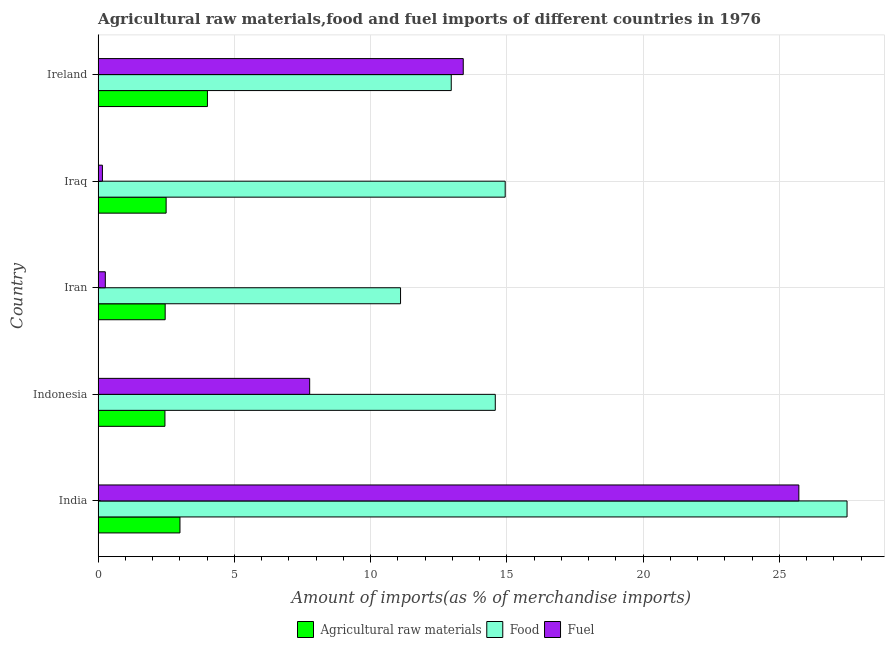How many groups of bars are there?
Give a very brief answer. 5. Are the number of bars on each tick of the Y-axis equal?
Provide a succinct answer. Yes. How many bars are there on the 3rd tick from the bottom?
Your response must be concise. 3. What is the label of the 4th group of bars from the top?
Offer a terse response. Indonesia. In how many cases, is the number of bars for a given country not equal to the number of legend labels?
Offer a terse response. 0. What is the percentage of raw materials imports in Iran?
Make the answer very short. 2.46. Across all countries, what is the maximum percentage of fuel imports?
Keep it short and to the point. 25.71. Across all countries, what is the minimum percentage of fuel imports?
Your response must be concise. 0.16. In which country was the percentage of food imports minimum?
Ensure brevity in your answer.  Iran. What is the total percentage of food imports in the graph?
Give a very brief answer. 81.05. What is the difference between the percentage of fuel imports in Indonesia and that in Ireland?
Provide a short and direct response. -5.63. What is the difference between the percentage of food imports in Ireland and the percentage of fuel imports in India?
Provide a succinct answer. -12.75. What is the average percentage of fuel imports per country?
Offer a terse response. 9.46. What is the difference between the percentage of raw materials imports and percentage of fuel imports in Iraq?
Ensure brevity in your answer.  2.34. In how many countries, is the percentage of raw materials imports greater than 3 %?
Ensure brevity in your answer.  2. What is the ratio of the percentage of food imports in India to that in Iraq?
Make the answer very short. 1.84. Is the percentage of raw materials imports in Indonesia less than that in Iraq?
Give a very brief answer. Yes. Is the difference between the percentage of raw materials imports in India and Ireland greater than the difference between the percentage of fuel imports in India and Ireland?
Offer a terse response. No. What is the difference between the highest and the second highest percentage of food imports?
Make the answer very short. 12.54. What is the difference between the highest and the lowest percentage of raw materials imports?
Ensure brevity in your answer.  1.56. In how many countries, is the percentage of fuel imports greater than the average percentage of fuel imports taken over all countries?
Offer a terse response. 2. What does the 3rd bar from the top in Iran represents?
Provide a short and direct response. Agricultural raw materials. What does the 1st bar from the bottom in Indonesia represents?
Provide a succinct answer. Agricultural raw materials. How many bars are there?
Your answer should be compact. 15. What is the difference between two consecutive major ticks on the X-axis?
Your answer should be compact. 5. Are the values on the major ticks of X-axis written in scientific E-notation?
Provide a succinct answer. No. Where does the legend appear in the graph?
Your answer should be compact. Bottom center. How are the legend labels stacked?
Ensure brevity in your answer.  Horizontal. What is the title of the graph?
Provide a short and direct response. Agricultural raw materials,food and fuel imports of different countries in 1976. What is the label or title of the X-axis?
Provide a short and direct response. Amount of imports(as % of merchandise imports). What is the Amount of imports(as % of merchandise imports) of Agricultural raw materials in India?
Keep it short and to the point. 3. What is the Amount of imports(as % of merchandise imports) of Food in India?
Provide a short and direct response. 27.48. What is the Amount of imports(as % of merchandise imports) of Fuel in India?
Offer a terse response. 25.71. What is the Amount of imports(as % of merchandise imports) of Agricultural raw materials in Indonesia?
Your response must be concise. 2.45. What is the Amount of imports(as % of merchandise imports) in Food in Indonesia?
Provide a succinct answer. 14.57. What is the Amount of imports(as % of merchandise imports) of Fuel in Indonesia?
Offer a terse response. 7.76. What is the Amount of imports(as % of merchandise imports) in Agricultural raw materials in Iran?
Your answer should be very brief. 2.46. What is the Amount of imports(as % of merchandise imports) of Food in Iran?
Offer a terse response. 11.1. What is the Amount of imports(as % of merchandise imports) in Fuel in Iran?
Your answer should be very brief. 0.26. What is the Amount of imports(as % of merchandise imports) in Agricultural raw materials in Iraq?
Ensure brevity in your answer.  2.5. What is the Amount of imports(as % of merchandise imports) of Food in Iraq?
Provide a succinct answer. 14.94. What is the Amount of imports(as % of merchandise imports) in Fuel in Iraq?
Your answer should be compact. 0.16. What is the Amount of imports(as % of merchandise imports) of Agricultural raw materials in Ireland?
Your answer should be compact. 4.01. What is the Amount of imports(as % of merchandise imports) in Food in Ireland?
Your response must be concise. 12.96. What is the Amount of imports(as % of merchandise imports) of Fuel in Ireland?
Give a very brief answer. 13.4. Across all countries, what is the maximum Amount of imports(as % of merchandise imports) in Agricultural raw materials?
Provide a succinct answer. 4.01. Across all countries, what is the maximum Amount of imports(as % of merchandise imports) of Food?
Your answer should be compact. 27.48. Across all countries, what is the maximum Amount of imports(as % of merchandise imports) of Fuel?
Keep it short and to the point. 25.71. Across all countries, what is the minimum Amount of imports(as % of merchandise imports) in Agricultural raw materials?
Provide a short and direct response. 2.45. Across all countries, what is the minimum Amount of imports(as % of merchandise imports) of Food?
Your answer should be compact. 11.1. Across all countries, what is the minimum Amount of imports(as % of merchandise imports) in Fuel?
Provide a short and direct response. 0.16. What is the total Amount of imports(as % of merchandise imports) in Agricultural raw materials in the graph?
Provide a succinct answer. 14.42. What is the total Amount of imports(as % of merchandise imports) in Food in the graph?
Your answer should be compact. 81.05. What is the total Amount of imports(as % of merchandise imports) of Fuel in the graph?
Offer a very short reply. 47.29. What is the difference between the Amount of imports(as % of merchandise imports) in Agricultural raw materials in India and that in Indonesia?
Ensure brevity in your answer.  0.55. What is the difference between the Amount of imports(as % of merchandise imports) in Food in India and that in Indonesia?
Keep it short and to the point. 12.91. What is the difference between the Amount of imports(as % of merchandise imports) in Fuel in India and that in Indonesia?
Provide a succinct answer. 17.95. What is the difference between the Amount of imports(as % of merchandise imports) of Agricultural raw materials in India and that in Iran?
Offer a very short reply. 0.54. What is the difference between the Amount of imports(as % of merchandise imports) in Food in India and that in Iran?
Offer a very short reply. 16.38. What is the difference between the Amount of imports(as % of merchandise imports) in Fuel in India and that in Iran?
Your response must be concise. 25.45. What is the difference between the Amount of imports(as % of merchandise imports) of Agricultural raw materials in India and that in Iraq?
Make the answer very short. 0.51. What is the difference between the Amount of imports(as % of merchandise imports) of Food in India and that in Iraq?
Your response must be concise. 12.54. What is the difference between the Amount of imports(as % of merchandise imports) in Fuel in India and that in Iraq?
Make the answer very short. 25.55. What is the difference between the Amount of imports(as % of merchandise imports) of Agricultural raw materials in India and that in Ireland?
Offer a terse response. -1.01. What is the difference between the Amount of imports(as % of merchandise imports) in Food in India and that in Ireland?
Keep it short and to the point. 14.52. What is the difference between the Amount of imports(as % of merchandise imports) of Fuel in India and that in Ireland?
Provide a succinct answer. 12.31. What is the difference between the Amount of imports(as % of merchandise imports) in Agricultural raw materials in Indonesia and that in Iran?
Provide a succinct answer. -0.01. What is the difference between the Amount of imports(as % of merchandise imports) in Food in Indonesia and that in Iran?
Offer a very short reply. 3.48. What is the difference between the Amount of imports(as % of merchandise imports) in Fuel in Indonesia and that in Iran?
Offer a terse response. 7.5. What is the difference between the Amount of imports(as % of merchandise imports) of Agricultural raw materials in Indonesia and that in Iraq?
Keep it short and to the point. -0.04. What is the difference between the Amount of imports(as % of merchandise imports) of Food in Indonesia and that in Iraq?
Your answer should be very brief. -0.36. What is the difference between the Amount of imports(as % of merchandise imports) in Fuel in Indonesia and that in Iraq?
Give a very brief answer. 7.6. What is the difference between the Amount of imports(as % of merchandise imports) in Agricultural raw materials in Indonesia and that in Ireland?
Ensure brevity in your answer.  -1.56. What is the difference between the Amount of imports(as % of merchandise imports) of Food in Indonesia and that in Ireland?
Make the answer very short. 1.62. What is the difference between the Amount of imports(as % of merchandise imports) of Fuel in Indonesia and that in Ireland?
Provide a short and direct response. -5.64. What is the difference between the Amount of imports(as % of merchandise imports) in Agricultural raw materials in Iran and that in Iraq?
Ensure brevity in your answer.  -0.04. What is the difference between the Amount of imports(as % of merchandise imports) in Food in Iran and that in Iraq?
Your response must be concise. -3.84. What is the difference between the Amount of imports(as % of merchandise imports) in Fuel in Iran and that in Iraq?
Make the answer very short. 0.11. What is the difference between the Amount of imports(as % of merchandise imports) in Agricultural raw materials in Iran and that in Ireland?
Keep it short and to the point. -1.55. What is the difference between the Amount of imports(as % of merchandise imports) in Food in Iran and that in Ireland?
Make the answer very short. -1.86. What is the difference between the Amount of imports(as % of merchandise imports) in Fuel in Iran and that in Ireland?
Make the answer very short. -13.13. What is the difference between the Amount of imports(as % of merchandise imports) in Agricultural raw materials in Iraq and that in Ireland?
Provide a succinct answer. -1.52. What is the difference between the Amount of imports(as % of merchandise imports) in Food in Iraq and that in Ireland?
Ensure brevity in your answer.  1.98. What is the difference between the Amount of imports(as % of merchandise imports) of Fuel in Iraq and that in Ireland?
Offer a very short reply. -13.24. What is the difference between the Amount of imports(as % of merchandise imports) of Agricultural raw materials in India and the Amount of imports(as % of merchandise imports) of Food in Indonesia?
Your answer should be very brief. -11.57. What is the difference between the Amount of imports(as % of merchandise imports) in Agricultural raw materials in India and the Amount of imports(as % of merchandise imports) in Fuel in Indonesia?
Ensure brevity in your answer.  -4.76. What is the difference between the Amount of imports(as % of merchandise imports) in Food in India and the Amount of imports(as % of merchandise imports) in Fuel in Indonesia?
Make the answer very short. 19.72. What is the difference between the Amount of imports(as % of merchandise imports) in Agricultural raw materials in India and the Amount of imports(as % of merchandise imports) in Food in Iran?
Provide a short and direct response. -8.09. What is the difference between the Amount of imports(as % of merchandise imports) of Agricultural raw materials in India and the Amount of imports(as % of merchandise imports) of Fuel in Iran?
Provide a succinct answer. 2.74. What is the difference between the Amount of imports(as % of merchandise imports) of Food in India and the Amount of imports(as % of merchandise imports) of Fuel in Iran?
Keep it short and to the point. 27.22. What is the difference between the Amount of imports(as % of merchandise imports) in Agricultural raw materials in India and the Amount of imports(as % of merchandise imports) in Food in Iraq?
Offer a terse response. -11.93. What is the difference between the Amount of imports(as % of merchandise imports) in Agricultural raw materials in India and the Amount of imports(as % of merchandise imports) in Fuel in Iraq?
Keep it short and to the point. 2.85. What is the difference between the Amount of imports(as % of merchandise imports) of Food in India and the Amount of imports(as % of merchandise imports) of Fuel in Iraq?
Give a very brief answer. 27.32. What is the difference between the Amount of imports(as % of merchandise imports) of Agricultural raw materials in India and the Amount of imports(as % of merchandise imports) of Food in Ireland?
Provide a succinct answer. -9.95. What is the difference between the Amount of imports(as % of merchandise imports) in Agricultural raw materials in India and the Amount of imports(as % of merchandise imports) in Fuel in Ireland?
Your response must be concise. -10.39. What is the difference between the Amount of imports(as % of merchandise imports) in Food in India and the Amount of imports(as % of merchandise imports) in Fuel in Ireland?
Make the answer very short. 14.08. What is the difference between the Amount of imports(as % of merchandise imports) of Agricultural raw materials in Indonesia and the Amount of imports(as % of merchandise imports) of Food in Iran?
Provide a succinct answer. -8.65. What is the difference between the Amount of imports(as % of merchandise imports) in Agricultural raw materials in Indonesia and the Amount of imports(as % of merchandise imports) in Fuel in Iran?
Offer a very short reply. 2.19. What is the difference between the Amount of imports(as % of merchandise imports) in Food in Indonesia and the Amount of imports(as % of merchandise imports) in Fuel in Iran?
Offer a terse response. 14.31. What is the difference between the Amount of imports(as % of merchandise imports) of Agricultural raw materials in Indonesia and the Amount of imports(as % of merchandise imports) of Food in Iraq?
Provide a short and direct response. -12.48. What is the difference between the Amount of imports(as % of merchandise imports) in Agricultural raw materials in Indonesia and the Amount of imports(as % of merchandise imports) in Fuel in Iraq?
Provide a short and direct response. 2.29. What is the difference between the Amount of imports(as % of merchandise imports) in Food in Indonesia and the Amount of imports(as % of merchandise imports) in Fuel in Iraq?
Keep it short and to the point. 14.42. What is the difference between the Amount of imports(as % of merchandise imports) of Agricultural raw materials in Indonesia and the Amount of imports(as % of merchandise imports) of Food in Ireland?
Offer a very short reply. -10.51. What is the difference between the Amount of imports(as % of merchandise imports) of Agricultural raw materials in Indonesia and the Amount of imports(as % of merchandise imports) of Fuel in Ireland?
Make the answer very short. -10.95. What is the difference between the Amount of imports(as % of merchandise imports) of Food in Indonesia and the Amount of imports(as % of merchandise imports) of Fuel in Ireland?
Provide a succinct answer. 1.18. What is the difference between the Amount of imports(as % of merchandise imports) in Agricultural raw materials in Iran and the Amount of imports(as % of merchandise imports) in Food in Iraq?
Ensure brevity in your answer.  -12.48. What is the difference between the Amount of imports(as % of merchandise imports) in Agricultural raw materials in Iran and the Amount of imports(as % of merchandise imports) in Fuel in Iraq?
Offer a terse response. 2.3. What is the difference between the Amount of imports(as % of merchandise imports) in Food in Iran and the Amount of imports(as % of merchandise imports) in Fuel in Iraq?
Provide a succinct answer. 10.94. What is the difference between the Amount of imports(as % of merchandise imports) of Agricultural raw materials in Iran and the Amount of imports(as % of merchandise imports) of Food in Ireland?
Provide a succinct answer. -10.5. What is the difference between the Amount of imports(as % of merchandise imports) in Agricultural raw materials in Iran and the Amount of imports(as % of merchandise imports) in Fuel in Ireland?
Offer a terse response. -10.94. What is the difference between the Amount of imports(as % of merchandise imports) in Food in Iran and the Amount of imports(as % of merchandise imports) in Fuel in Ireland?
Provide a short and direct response. -2.3. What is the difference between the Amount of imports(as % of merchandise imports) of Agricultural raw materials in Iraq and the Amount of imports(as % of merchandise imports) of Food in Ireland?
Provide a succinct answer. -10.46. What is the difference between the Amount of imports(as % of merchandise imports) of Agricultural raw materials in Iraq and the Amount of imports(as % of merchandise imports) of Fuel in Ireland?
Make the answer very short. -10.9. What is the difference between the Amount of imports(as % of merchandise imports) of Food in Iraq and the Amount of imports(as % of merchandise imports) of Fuel in Ireland?
Give a very brief answer. 1.54. What is the average Amount of imports(as % of merchandise imports) of Agricultural raw materials per country?
Give a very brief answer. 2.88. What is the average Amount of imports(as % of merchandise imports) in Food per country?
Your response must be concise. 16.21. What is the average Amount of imports(as % of merchandise imports) of Fuel per country?
Your response must be concise. 9.46. What is the difference between the Amount of imports(as % of merchandise imports) of Agricultural raw materials and Amount of imports(as % of merchandise imports) of Food in India?
Your answer should be very brief. -24.48. What is the difference between the Amount of imports(as % of merchandise imports) of Agricultural raw materials and Amount of imports(as % of merchandise imports) of Fuel in India?
Your answer should be compact. -22.71. What is the difference between the Amount of imports(as % of merchandise imports) in Food and Amount of imports(as % of merchandise imports) in Fuel in India?
Provide a short and direct response. 1.77. What is the difference between the Amount of imports(as % of merchandise imports) of Agricultural raw materials and Amount of imports(as % of merchandise imports) of Food in Indonesia?
Provide a short and direct response. -12.12. What is the difference between the Amount of imports(as % of merchandise imports) of Agricultural raw materials and Amount of imports(as % of merchandise imports) of Fuel in Indonesia?
Provide a short and direct response. -5.31. What is the difference between the Amount of imports(as % of merchandise imports) in Food and Amount of imports(as % of merchandise imports) in Fuel in Indonesia?
Offer a terse response. 6.81. What is the difference between the Amount of imports(as % of merchandise imports) in Agricultural raw materials and Amount of imports(as % of merchandise imports) in Food in Iran?
Offer a terse response. -8.64. What is the difference between the Amount of imports(as % of merchandise imports) of Agricultural raw materials and Amount of imports(as % of merchandise imports) of Fuel in Iran?
Provide a short and direct response. 2.2. What is the difference between the Amount of imports(as % of merchandise imports) of Food and Amount of imports(as % of merchandise imports) of Fuel in Iran?
Offer a very short reply. 10.83. What is the difference between the Amount of imports(as % of merchandise imports) in Agricultural raw materials and Amount of imports(as % of merchandise imports) in Food in Iraq?
Your answer should be compact. -12.44. What is the difference between the Amount of imports(as % of merchandise imports) in Agricultural raw materials and Amount of imports(as % of merchandise imports) in Fuel in Iraq?
Provide a short and direct response. 2.34. What is the difference between the Amount of imports(as % of merchandise imports) in Food and Amount of imports(as % of merchandise imports) in Fuel in Iraq?
Ensure brevity in your answer.  14.78. What is the difference between the Amount of imports(as % of merchandise imports) of Agricultural raw materials and Amount of imports(as % of merchandise imports) of Food in Ireland?
Give a very brief answer. -8.95. What is the difference between the Amount of imports(as % of merchandise imports) in Agricultural raw materials and Amount of imports(as % of merchandise imports) in Fuel in Ireland?
Make the answer very short. -9.39. What is the difference between the Amount of imports(as % of merchandise imports) in Food and Amount of imports(as % of merchandise imports) in Fuel in Ireland?
Give a very brief answer. -0.44. What is the ratio of the Amount of imports(as % of merchandise imports) in Agricultural raw materials in India to that in Indonesia?
Offer a very short reply. 1.22. What is the ratio of the Amount of imports(as % of merchandise imports) of Food in India to that in Indonesia?
Make the answer very short. 1.89. What is the ratio of the Amount of imports(as % of merchandise imports) of Fuel in India to that in Indonesia?
Ensure brevity in your answer.  3.31. What is the ratio of the Amount of imports(as % of merchandise imports) of Agricultural raw materials in India to that in Iran?
Your response must be concise. 1.22. What is the ratio of the Amount of imports(as % of merchandise imports) of Food in India to that in Iran?
Your answer should be compact. 2.48. What is the ratio of the Amount of imports(as % of merchandise imports) in Fuel in India to that in Iran?
Your response must be concise. 97.29. What is the ratio of the Amount of imports(as % of merchandise imports) in Agricultural raw materials in India to that in Iraq?
Provide a succinct answer. 1.2. What is the ratio of the Amount of imports(as % of merchandise imports) in Food in India to that in Iraq?
Provide a short and direct response. 1.84. What is the ratio of the Amount of imports(as % of merchandise imports) of Fuel in India to that in Iraq?
Provide a succinct answer. 162.75. What is the ratio of the Amount of imports(as % of merchandise imports) in Agricultural raw materials in India to that in Ireland?
Give a very brief answer. 0.75. What is the ratio of the Amount of imports(as % of merchandise imports) in Food in India to that in Ireland?
Keep it short and to the point. 2.12. What is the ratio of the Amount of imports(as % of merchandise imports) in Fuel in India to that in Ireland?
Your answer should be very brief. 1.92. What is the ratio of the Amount of imports(as % of merchandise imports) in Food in Indonesia to that in Iran?
Your answer should be compact. 1.31. What is the ratio of the Amount of imports(as % of merchandise imports) of Fuel in Indonesia to that in Iran?
Provide a succinct answer. 29.37. What is the ratio of the Amount of imports(as % of merchandise imports) of Agricultural raw materials in Indonesia to that in Iraq?
Give a very brief answer. 0.98. What is the ratio of the Amount of imports(as % of merchandise imports) of Food in Indonesia to that in Iraq?
Your answer should be compact. 0.98. What is the ratio of the Amount of imports(as % of merchandise imports) in Fuel in Indonesia to that in Iraq?
Offer a very short reply. 49.14. What is the ratio of the Amount of imports(as % of merchandise imports) in Agricultural raw materials in Indonesia to that in Ireland?
Keep it short and to the point. 0.61. What is the ratio of the Amount of imports(as % of merchandise imports) of Food in Indonesia to that in Ireland?
Ensure brevity in your answer.  1.12. What is the ratio of the Amount of imports(as % of merchandise imports) of Fuel in Indonesia to that in Ireland?
Offer a terse response. 0.58. What is the ratio of the Amount of imports(as % of merchandise imports) of Agricultural raw materials in Iran to that in Iraq?
Keep it short and to the point. 0.99. What is the ratio of the Amount of imports(as % of merchandise imports) of Food in Iran to that in Iraq?
Offer a terse response. 0.74. What is the ratio of the Amount of imports(as % of merchandise imports) of Fuel in Iran to that in Iraq?
Your answer should be compact. 1.67. What is the ratio of the Amount of imports(as % of merchandise imports) of Agricultural raw materials in Iran to that in Ireland?
Provide a succinct answer. 0.61. What is the ratio of the Amount of imports(as % of merchandise imports) of Food in Iran to that in Ireland?
Offer a terse response. 0.86. What is the ratio of the Amount of imports(as % of merchandise imports) of Fuel in Iran to that in Ireland?
Provide a succinct answer. 0.02. What is the ratio of the Amount of imports(as % of merchandise imports) in Agricultural raw materials in Iraq to that in Ireland?
Your answer should be very brief. 0.62. What is the ratio of the Amount of imports(as % of merchandise imports) in Food in Iraq to that in Ireland?
Your response must be concise. 1.15. What is the ratio of the Amount of imports(as % of merchandise imports) in Fuel in Iraq to that in Ireland?
Your answer should be very brief. 0.01. What is the difference between the highest and the second highest Amount of imports(as % of merchandise imports) of Agricultural raw materials?
Offer a terse response. 1.01. What is the difference between the highest and the second highest Amount of imports(as % of merchandise imports) in Food?
Give a very brief answer. 12.54. What is the difference between the highest and the second highest Amount of imports(as % of merchandise imports) of Fuel?
Offer a very short reply. 12.31. What is the difference between the highest and the lowest Amount of imports(as % of merchandise imports) in Agricultural raw materials?
Your response must be concise. 1.56. What is the difference between the highest and the lowest Amount of imports(as % of merchandise imports) of Food?
Provide a short and direct response. 16.38. What is the difference between the highest and the lowest Amount of imports(as % of merchandise imports) of Fuel?
Your response must be concise. 25.55. 